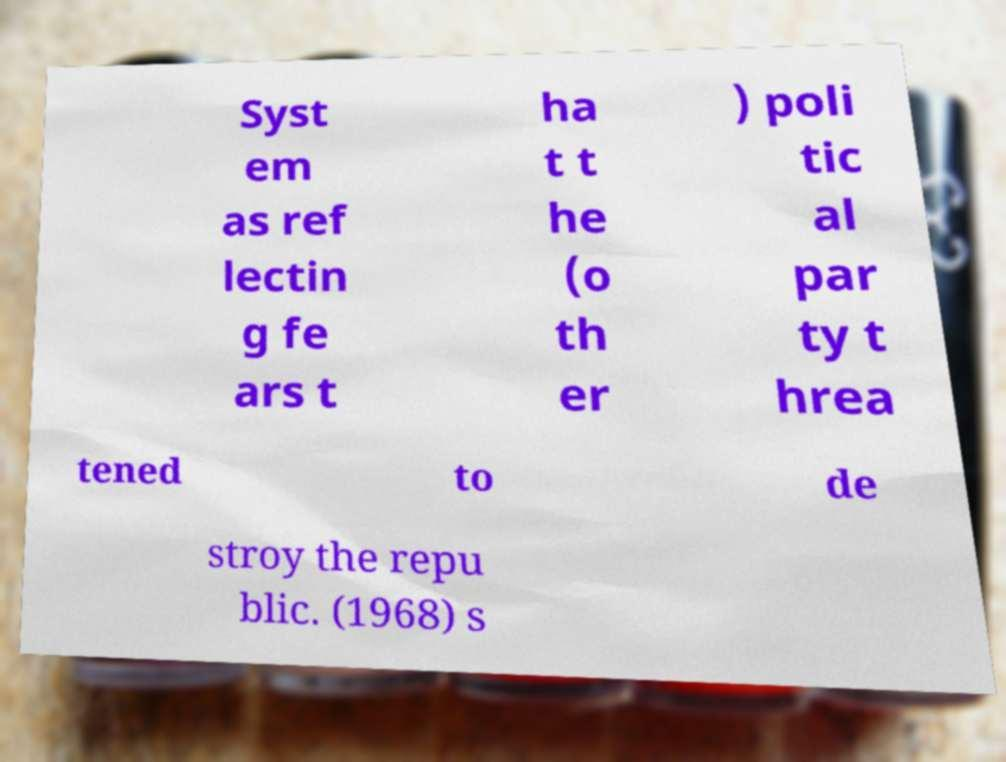Could you assist in decoding the text presented in this image and type it out clearly? Syst em as ref lectin g fe ars t ha t t he (o th er ) poli tic al par ty t hrea tened to de stroy the repu blic. (1968) s 